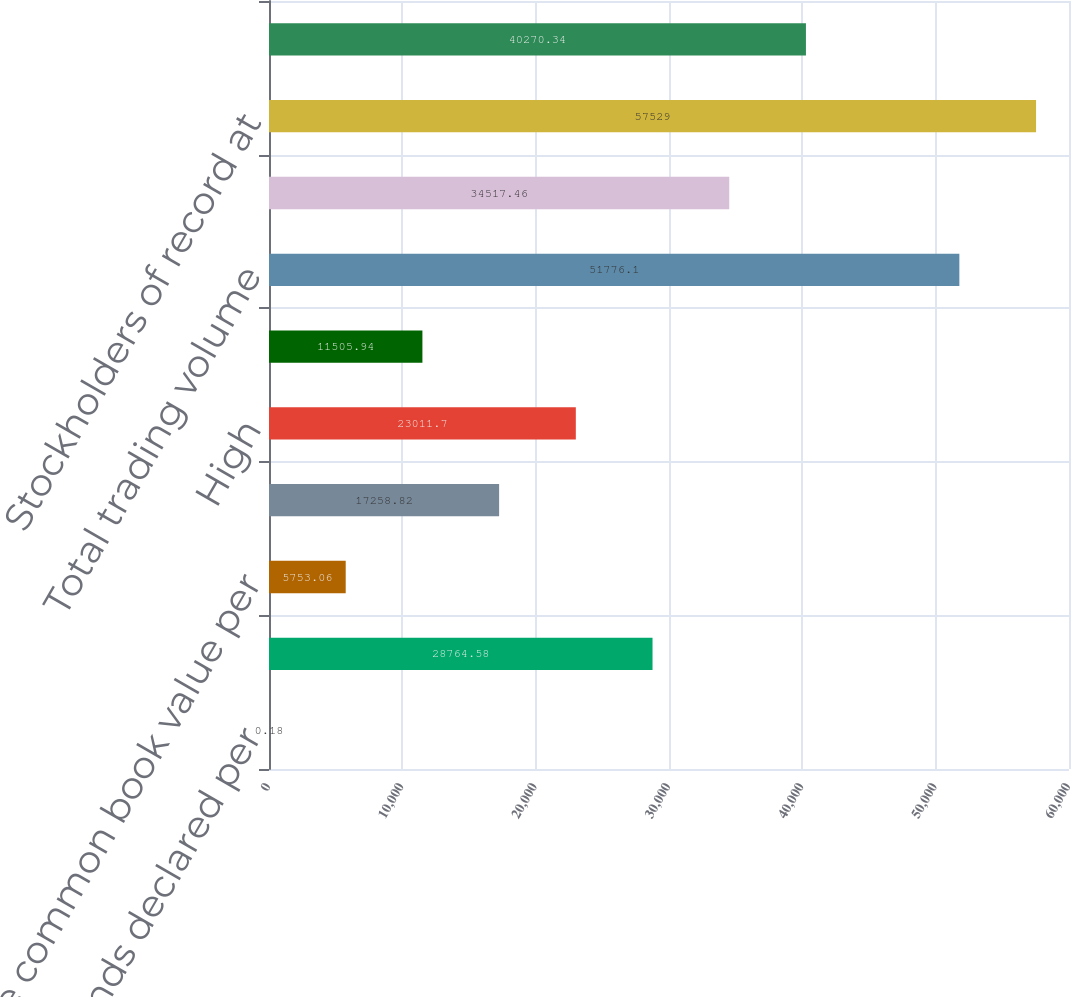<chart> <loc_0><loc_0><loc_500><loc_500><bar_chart><fcel>Cash dividends declared per<fcel>Common equity book value per<fcel>Tangible common book value per<fcel>Market value at year-end<fcel>High<fcel>Low<fcel>Total trading volume<fcel>Dividend payout ratio<fcel>Stockholders of record at<fcel>Basic<nl><fcel>0.18<fcel>28764.6<fcel>5753.06<fcel>17258.8<fcel>23011.7<fcel>11505.9<fcel>51776.1<fcel>34517.5<fcel>57529<fcel>40270.3<nl></chart> 